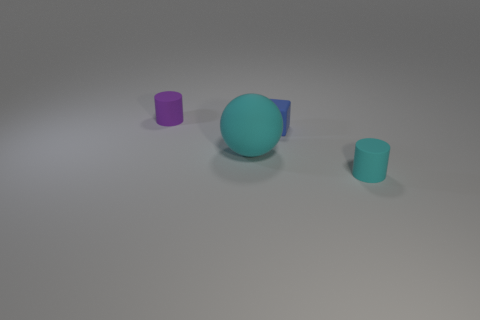What are the properties of light and shadow in this image? The image shows a subtle play of light and shadow, yielding soft-edged shadows that hint at a diffuse light source. The lighting is not too harsh, allowing the colors of the objects to remain vivid yet soft. 